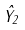<formula> <loc_0><loc_0><loc_500><loc_500>\hat { Y } _ { 2 }</formula> 